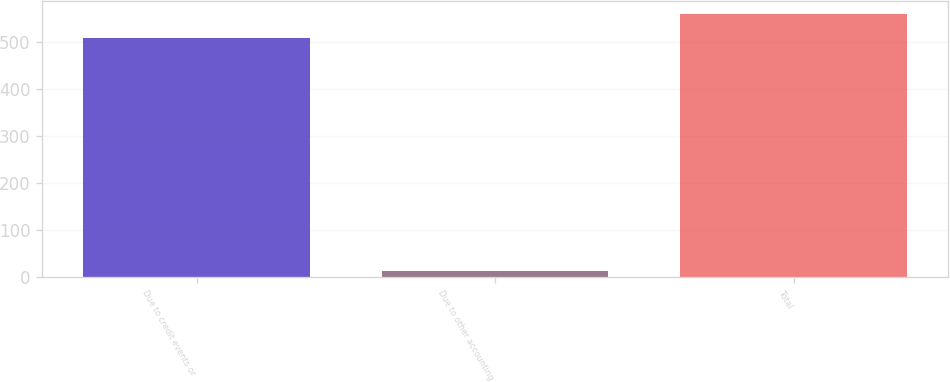Convert chart. <chart><loc_0><loc_0><loc_500><loc_500><bar_chart><fcel>Due to credit events or<fcel>Due to other accounting<fcel>Total<nl><fcel>508<fcel>12<fcel>558.8<nl></chart> 